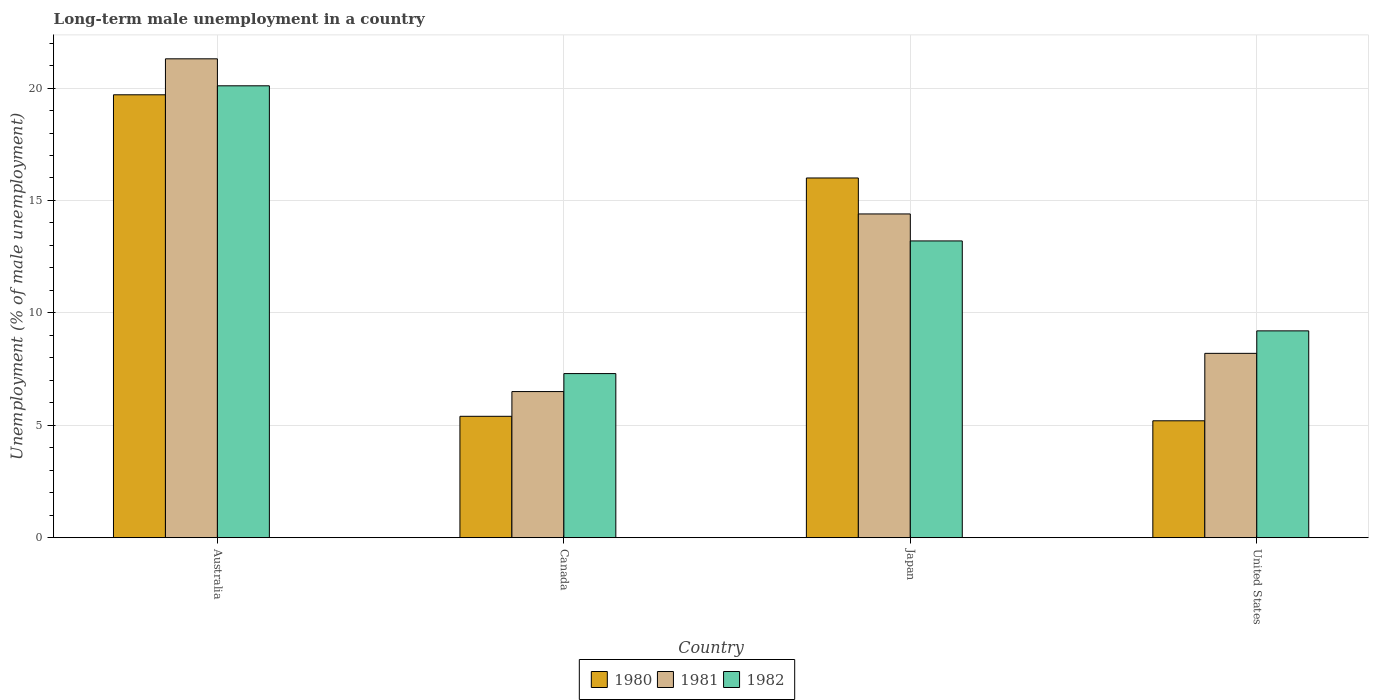How many groups of bars are there?
Make the answer very short. 4. Are the number of bars on each tick of the X-axis equal?
Offer a terse response. Yes. What is the label of the 3rd group of bars from the left?
Give a very brief answer. Japan. What is the percentage of long-term unemployed male population in 1981 in United States?
Offer a terse response. 8.2. Across all countries, what is the maximum percentage of long-term unemployed male population in 1981?
Provide a short and direct response. 21.3. Across all countries, what is the minimum percentage of long-term unemployed male population in 1982?
Your response must be concise. 7.3. In which country was the percentage of long-term unemployed male population in 1980 maximum?
Offer a very short reply. Australia. What is the total percentage of long-term unemployed male population in 1981 in the graph?
Your answer should be very brief. 50.4. What is the difference between the percentage of long-term unemployed male population in 1982 in Canada and that in United States?
Your response must be concise. -1.9. What is the difference between the percentage of long-term unemployed male population in 1980 in Japan and the percentage of long-term unemployed male population in 1981 in United States?
Give a very brief answer. 7.8. What is the average percentage of long-term unemployed male population in 1981 per country?
Your response must be concise. 12.6. What is the difference between the percentage of long-term unemployed male population of/in 1982 and percentage of long-term unemployed male population of/in 1980 in Australia?
Keep it short and to the point. 0.4. In how many countries, is the percentage of long-term unemployed male population in 1981 greater than 11 %?
Your response must be concise. 2. What is the ratio of the percentage of long-term unemployed male population in 1982 in Australia to that in Canada?
Provide a succinct answer. 2.75. Is the percentage of long-term unemployed male population in 1982 in Australia less than that in United States?
Provide a succinct answer. No. Is the difference between the percentage of long-term unemployed male population in 1982 in Australia and Japan greater than the difference between the percentage of long-term unemployed male population in 1980 in Australia and Japan?
Your answer should be very brief. Yes. What is the difference between the highest and the second highest percentage of long-term unemployed male population in 1980?
Your response must be concise. -3.7. What is the difference between the highest and the lowest percentage of long-term unemployed male population in 1980?
Your response must be concise. 14.5. Is the sum of the percentage of long-term unemployed male population in 1981 in Japan and United States greater than the maximum percentage of long-term unemployed male population in 1980 across all countries?
Provide a succinct answer. Yes. Is it the case that in every country, the sum of the percentage of long-term unemployed male population in 1980 and percentage of long-term unemployed male population in 1981 is greater than the percentage of long-term unemployed male population in 1982?
Make the answer very short. Yes. Are all the bars in the graph horizontal?
Your answer should be very brief. No. How many countries are there in the graph?
Give a very brief answer. 4. Does the graph contain grids?
Offer a very short reply. Yes. Where does the legend appear in the graph?
Provide a succinct answer. Bottom center. How many legend labels are there?
Ensure brevity in your answer.  3. What is the title of the graph?
Ensure brevity in your answer.  Long-term male unemployment in a country. What is the label or title of the Y-axis?
Your response must be concise. Unemployment (% of male unemployment). What is the Unemployment (% of male unemployment) in 1980 in Australia?
Keep it short and to the point. 19.7. What is the Unemployment (% of male unemployment) in 1981 in Australia?
Make the answer very short. 21.3. What is the Unemployment (% of male unemployment) in 1982 in Australia?
Provide a succinct answer. 20.1. What is the Unemployment (% of male unemployment) of 1980 in Canada?
Provide a succinct answer. 5.4. What is the Unemployment (% of male unemployment) of 1982 in Canada?
Give a very brief answer. 7.3. What is the Unemployment (% of male unemployment) of 1980 in Japan?
Keep it short and to the point. 16. What is the Unemployment (% of male unemployment) of 1981 in Japan?
Your answer should be compact. 14.4. What is the Unemployment (% of male unemployment) of 1982 in Japan?
Offer a terse response. 13.2. What is the Unemployment (% of male unemployment) of 1980 in United States?
Give a very brief answer. 5.2. What is the Unemployment (% of male unemployment) in 1981 in United States?
Offer a terse response. 8.2. What is the Unemployment (% of male unemployment) of 1982 in United States?
Keep it short and to the point. 9.2. Across all countries, what is the maximum Unemployment (% of male unemployment) in 1980?
Your answer should be compact. 19.7. Across all countries, what is the maximum Unemployment (% of male unemployment) in 1981?
Provide a succinct answer. 21.3. Across all countries, what is the maximum Unemployment (% of male unemployment) of 1982?
Make the answer very short. 20.1. Across all countries, what is the minimum Unemployment (% of male unemployment) in 1980?
Offer a very short reply. 5.2. Across all countries, what is the minimum Unemployment (% of male unemployment) of 1982?
Your answer should be very brief. 7.3. What is the total Unemployment (% of male unemployment) of 1980 in the graph?
Make the answer very short. 46.3. What is the total Unemployment (% of male unemployment) in 1981 in the graph?
Provide a short and direct response. 50.4. What is the total Unemployment (% of male unemployment) in 1982 in the graph?
Your answer should be compact. 49.8. What is the difference between the Unemployment (% of male unemployment) in 1981 in Australia and that in Canada?
Give a very brief answer. 14.8. What is the difference between the Unemployment (% of male unemployment) of 1981 in Australia and that in Japan?
Provide a succinct answer. 6.9. What is the difference between the Unemployment (% of male unemployment) of 1981 in Australia and that in United States?
Make the answer very short. 13.1. What is the difference between the Unemployment (% of male unemployment) in 1981 in Canada and that in Japan?
Your answer should be very brief. -7.9. What is the difference between the Unemployment (% of male unemployment) of 1982 in Canada and that in Japan?
Provide a short and direct response. -5.9. What is the difference between the Unemployment (% of male unemployment) in 1980 in Canada and that in United States?
Your answer should be very brief. 0.2. What is the difference between the Unemployment (% of male unemployment) of 1981 in Canada and that in United States?
Keep it short and to the point. -1.7. What is the difference between the Unemployment (% of male unemployment) of 1982 in Canada and that in United States?
Ensure brevity in your answer.  -1.9. What is the difference between the Unemployment (% of male unemployment) in 1982 in Japan and that in United States?
Offer a terse response. 4. What is the difference between the Unemployment (% of male unemployment) in 1980 in Australia and the Unemployment (% of male unemployment) in 1982 in Canada?
Offer a terse response. 12.4. What is the difference between the Unemployment (% of male unemployment) in 1981 in Australia and the Unemployment (% of male unemployment) in 1982 in Canada?
Offer a very short reply. 14. What is the difference between the Unemployment (% of male unemployment) in 1980 in Australia and the Unemployment (% of male unemployment) in 1981 in Japan?
Your answer should be very brief. 5.3. What is the difference between the Unemployment (% of male unemployment) of 1980 in Canada and the Unemployment (% of male unemployment) of 1981 in Japan?
Give a very brief answer. -9. What is the difference between the Unemployment (% of male unemployment) of 1981 in Canada and the Unemployment (% of male unemployment) of 1982 in Japan?
Your answer should be compact. -6.7. What is the difference between the Unemployment (% of male unemployment) in 1980 in Canada and the Unemployment (% of male unemployment) in 1981 in United States?
Provide a succinct answer. -2.8. What is the difference between the Unemployment (% of male unemployment) of 1980 in Canada and the Unemployment (% of male unemployment) of 1982 in United States?
Your answer should be very brief. -3.8. What is the difference between the Unemployment (% of male unemployment) of 1981 in Canada and the Unemployment (% of male unemployment) of 1982 in United States?
Keep it short and to the point. -2.7. What is the difference between the Unemployment (% of male unemployment) in 1980 in Japan and the Unemployment (% of male unemployment) in 1981 in United States?
Give a very brief answer. 7.8. What is the average Unemployment (% of male unemployment) in 1980 per country?
Offer a terse response. 11.57. What is the average Unemployment (% of male unemployment) in 1981 per country?
Offer a very short reply. 12.6. What is the average Unemployment (% of male unemployment) of 1982 per country?
Offer a terse response. 12.45. What is the difference between the Unemployment (% of male unemployment) of 1980 and Unemployment (% of male unemployment) of 1982 in Australia?
Offer a terse response. -0.4. What is the difference between the Unemployment (% of male unemployment) of 1981 and Unemployment (% of male unemployment) of 1982 in Australia?
Make the answer very short. 1.2. What is the difference between the Unemployment (% of male unemployment) in 1980 and Unemployment (% of male unemployment) in 1981 in Japan?
Offer a terse response. 1.6. What is the difference between the Unemployment (% of male unemployment) of 1980 and Unemployment (% of male unemployment) of 1982 in Japan?
Your answer should be very brief. 2.8. What is the difference between the Unemployment (% of male unemployment) in 1981 and Unemployment (% of male unemployment) in 1982 in Japan?
Ensure brevity in your answer.  1.2. What is the difference between the Unemployment (% of male unemployment) in 1980 and Unemployment (% of male unemployment) in 1981 in United States?
Keep it short and to the point. -3. What is the difference between the Unemployment (% of male unemployment) of 1980 and Unemployment (% of male unemployment) of 1982 in United States?
Make the answer very short. -4. What is the ratio of the Unemployment (% of male unemployment) of 1980 in Australia to that in Canada?
Provide a short and direct response. 3.65. What is the ratio of the Unemployment (% of male unemployment) in 1981 in Australia to that in Canada?
Your answer should be very brief. 3.28. What is the ratio of the Unemployment (% of male unemployment) in 1982 in Australia to that in Canada?
Your answer should be very brief. 2.75. What is the ratio of the Unemployment (% of male unemployment) of 1980 in Australia to that in Japan?
Your answer should be very brief. 1.23. What is the ratio of the Unemployment (% of male unemployment) of 1981 in Australia to that in Japan?
Your response must be concise. 1.48. What is the ratio of the Unemployment (% of male unemployment) in 1982 in Australia to that in Japan?
Your response must be concise. 1.52. What is the ratio of the Unemployment (% of male unemployment) in 1980 in Australia to that in United States?
Provide a succinct answer. 3.79. What is the ratio of the Unemployment (% of male unemployment) in 1981 in Australia to that in United States?
Offer a very short reply. 2.6. What is the ratio of the Unemployment (% of male unemployment) of 1982 in Australia to that in United States?
Offer a very short reply. 2.18. What is the ratio of the Unemployment (% of male unemployment) in 1980 in Canada to that in Japan?
Provide a succinct answer. 0.34. What is the ratio of the Unemployment (% of male unemployment) in 1981 in Canada to that in Japan?
Make the answer very short. 0.45. What is the ratio of the Unemployment (% of male unemployment) of 1982 in Canada to that in Japan?
Give a very brief answer. 0.55. What is the ratio of the Unemployment (% of male unemployment) of 1981 in Canada to that in United States?
Provide a succinct answer. 0.79. What is the ratio of the Unemployment (% of male unemployment) in 1982 in Canada to that in United States?
Your answer should be very brief. 0.79. What is the ratio of the Unemployment (% of male unemployment) in 1980 in Japan to that in United States?
Make the answer very short. 3.08. What is the ratio of the Unemployment (% of male unemployment) in 1981 in Japan to that in United States?
Keep it short and to the point. 1.76. What is the ratio of the Unemployment (% of male unemployment) in 1982 in Japan to that in United States?
Provide a short and direct response. 1.43. What is the difference between the highest and the second highest Unemployment (% of male unemployment) in 1980?
Your answer should be very brief. 3.7. What is the difference between the highest and the second highest Unemployment (% of male unemployment) in 1981?
Provide a short and direct response. 6.9. What is the difference between the highest and the second highest Unemployment (% of male unemployment) of 1982?
Your answer should be compact. 6.9. What is the difference between the highest and the lowest Unemployment (% of male unemployment) of 1980?
Your answer should be compact. 14.5. 